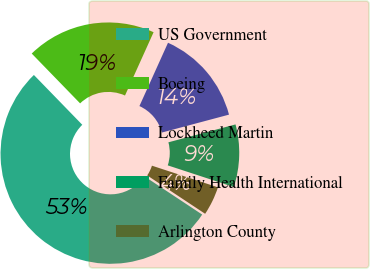Convert chart to OTSL. <chart><loc_0><loc_0><loc_500><loc_500><pie_chart><fcel>US Government<fcel>Boeing<fcel>Lockheed Martin<fcel>Family Health International<fcel>Arlington County<nl><fcel>53.42%<fcel>19.02%<fcel>14.1%<fcel>9.19%<fcel>4.27%<nl></chart> 